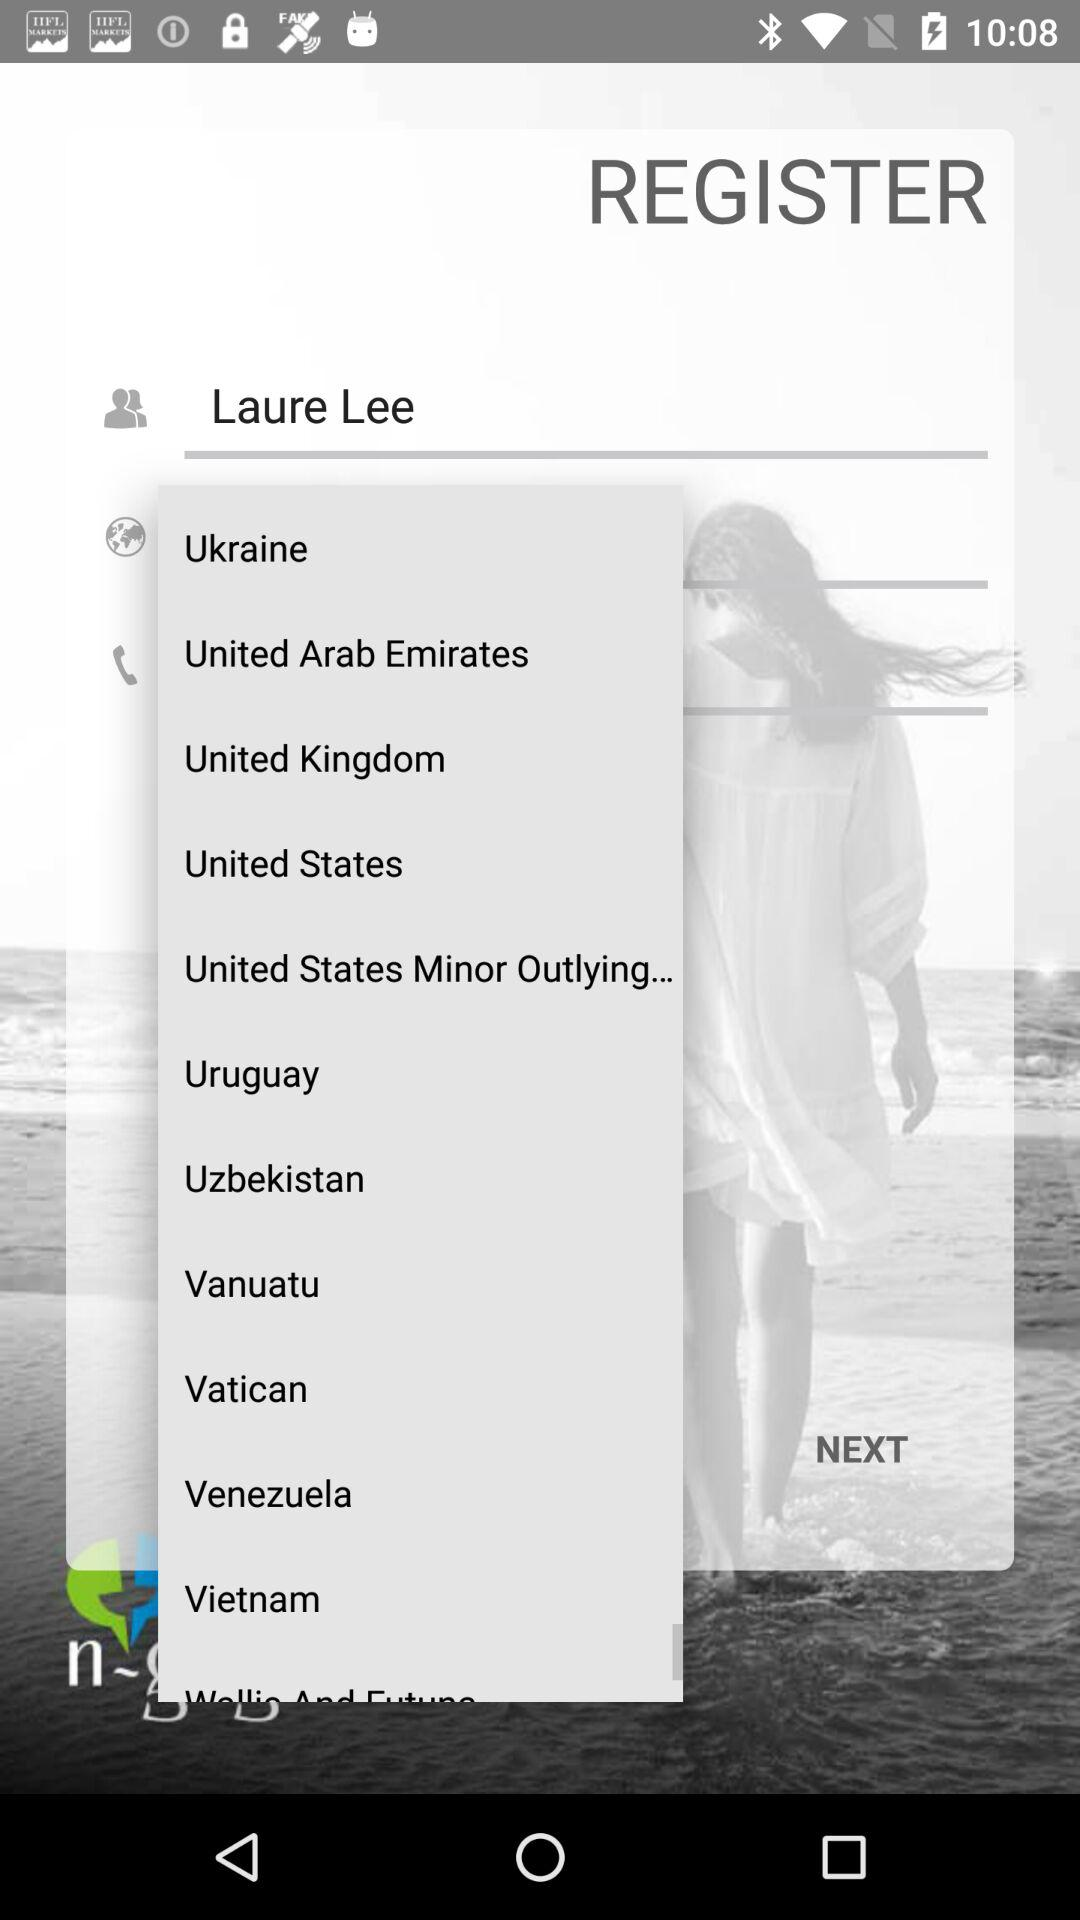What is the registered name? The registered name is Laure Lee. 